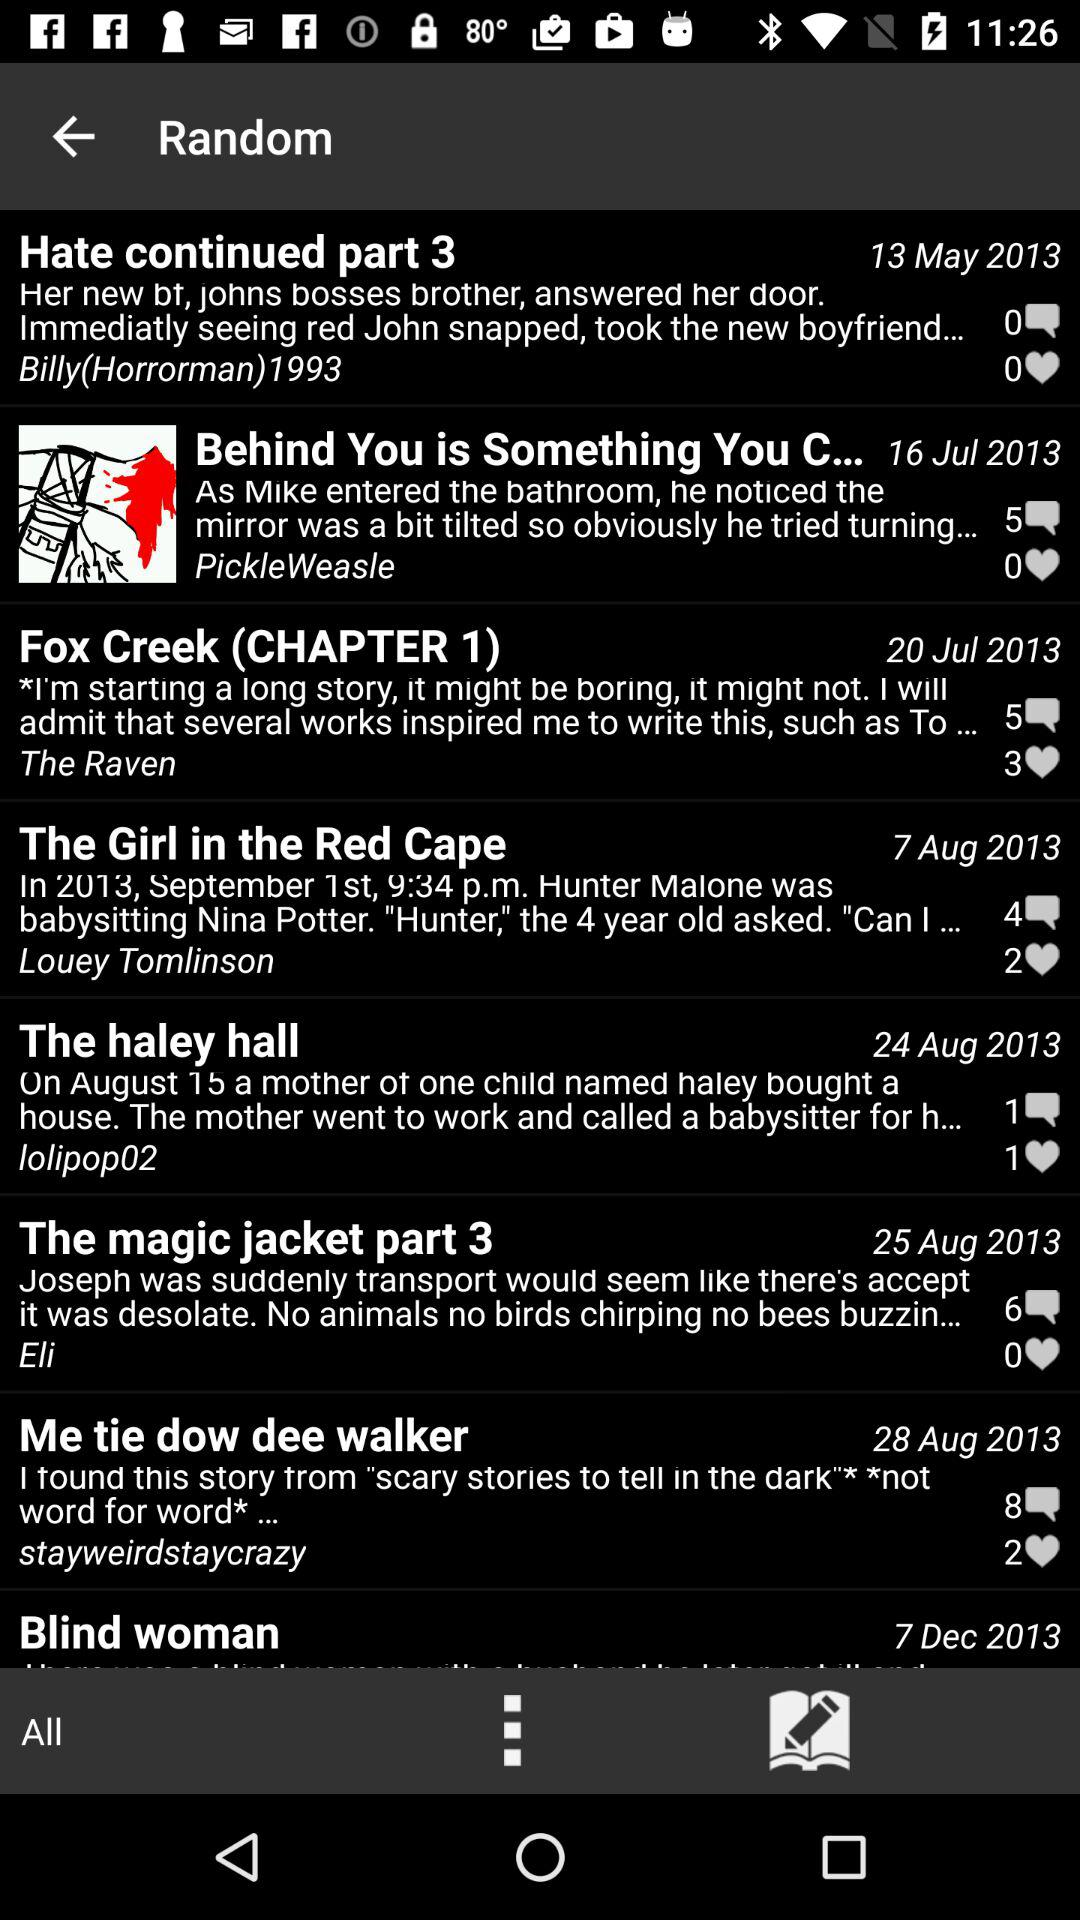Which post was published on August 24, 2013? The post that was published on August 24, 2013 is "The haley hall". 